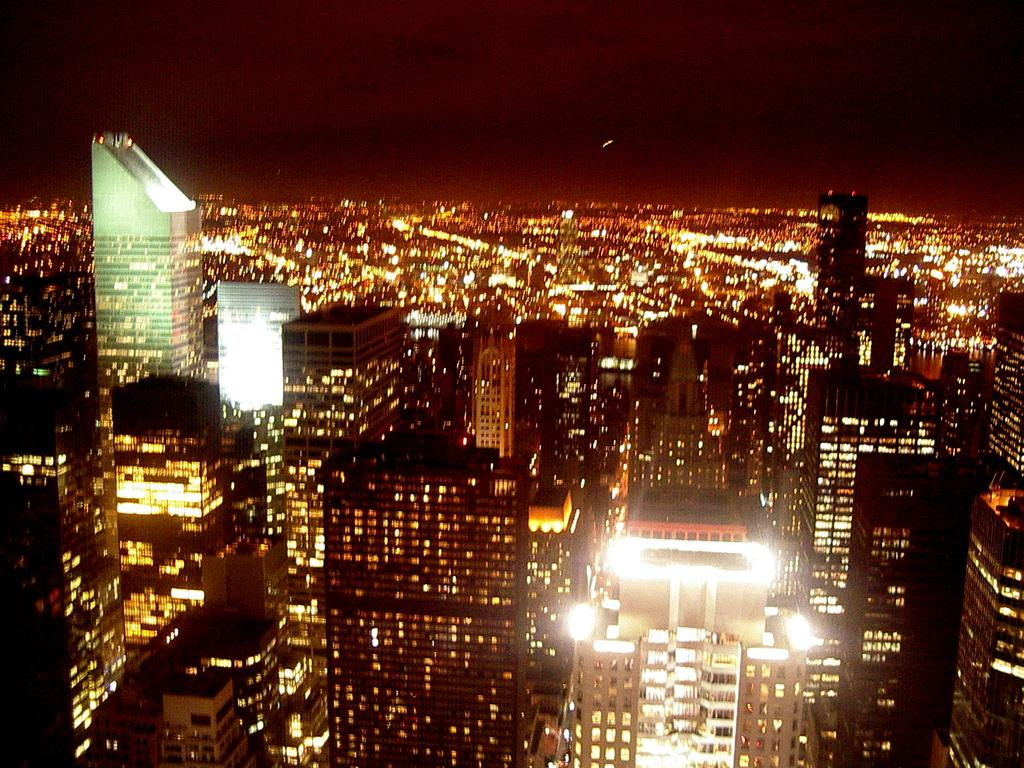What type of structures are visible in the image? There are many buildings with lights in the image. What can be seen in the background of the image? The sky is visible in the background of the image. What type of hook can be seen in the image? There is no hook present in the image. What type of war is depicted in the image? There is no war depicted in the image; it features buildings with lights and the sky. 